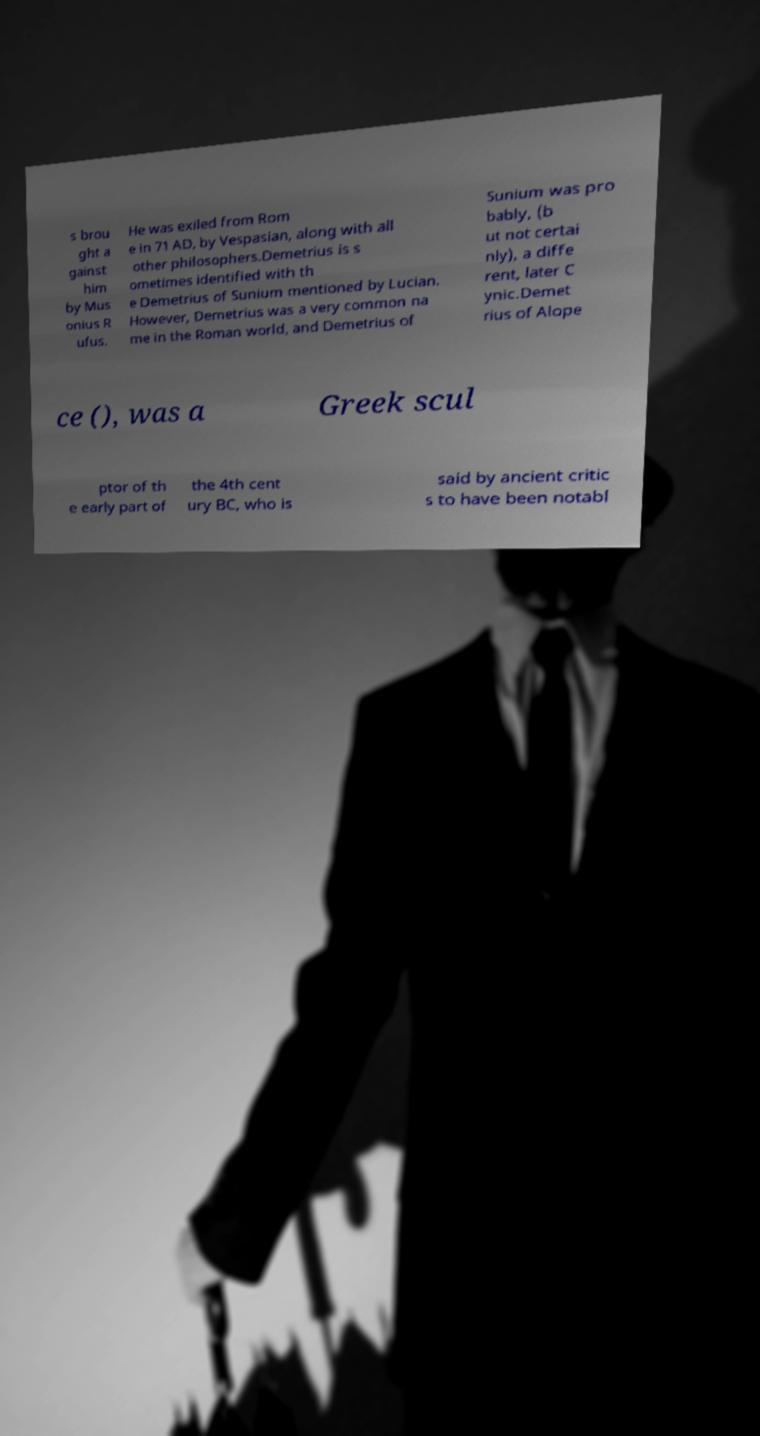Please identify and transcribe the text found in this image. s brou ght a gainst him by Mus onius R ufus. He was exiled from Rom e in 71 AD, by Vespasian, along with all other philosophers.Demetrius is s ometimes identified with th e Demetrius of Sunium mentioned by Lucian. However, Demetrius was a very common na me in the Roman world, and Demetrius of Sunium was pro bably, (b ut not certai nly), a diffe rent, later C ynic.Demet rius of Alope ce (), was a Greek scul ptor of th e early part of the 4th cent ury BC, who is said by ancient critic s to have been notabl 